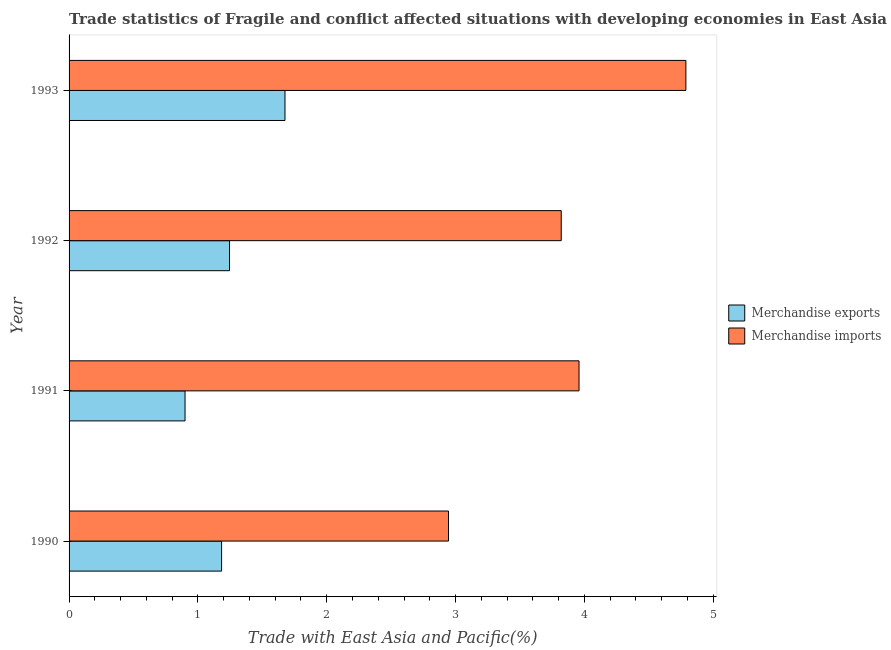How many groups of bars are there?
Make the answer very short. 4. Are the number of bars on each tick of the Y-axis equal?
Make the answer very short. Yes. In how many cases, is the number of bars for a given year not equal to the number of legend labels?
Keep it short and to the point. 0. What is the merchandise imports in 1991?
Offer a terse response. 3.96. Across all years, what is the maximum merchandise exports?
Provide a succinct answer. 1.68. Across all years, what is the minimum merchandise imports?
Keep it short and to the point. 2.95. What is the total merchandise imports in the graph?
Your response must be concise. 15.51. What is the difference between the merchandise exports in 1990 and that in 1992?
Your response must be concise. -0.06. What is the difference between the merchandise imports in 1990 and the merchandise exports in 1991?
Your answer should be very brief. 2.04. What is the average merchandise imports per year?
Keep it short and to the point. 3.88. In the year 1991, what is the difference between the merchandise exports and merchandise imports?
Ensure brevity in your answer.  -3.06. What is the ratio of the merchandise imports in 1991 to that in 1992?
Offer a very short reply. 1.04. Is the merchandise imports in 1990 less than that in 1992?
Your answer should be very brief. Yes. Is the difference between the merchandise exports in 1990 and 1991 greater than the difference between the merchandise imports in 1990 and 1991?
Offer a very short reply. Yes. What is the difference between the highest and the second highest merchandise imports?
Ensure brevity in your answer.  0.83. What is the difference between the highest and the lowest merchandise imports?
Provide a succinct answer. 1.84. In how many years, is the merchandise exports greater than the average merchandise exports taken over all years?
Provide a succinct answer. 1. Is the sum of the merchandise imports in 1990 and 1993 greater than the maximum merchandise exports across all years?
Ensure brevity in your answer.  Yes. What is the difference between two consecutive major ticks on the X-axis?
Your answer should be compact. 1. Are the values on the major ticks of X-axis written in scientific E-notation?
Give a very brief answer. No. Does the graph contain grids?
Provide a short and direct response. No. Where does the legend appear in the graph?
Give a very brief answer. Center right. How many legend labels are there?
Provide a succinct answer. 2. How are the legend labels stacked?
Offer a terse response. Vertical. What is the title of the graph?
Provide a short and direct response. Trade statistics of Fragile and conflict affected situations with developing economies in East Asia. Does "By country of asylum" appear as one of the legend labels in the graph?
Ensure brevity in your answer.  No. What is the label or title of the X-axis?
Provide a succinct answer. Trade with East Asia and Pacific(%). What is the label or title of the Y-axis?
Your answer should be very brief. Year. What is the Trade with East Asia and Pacific(%) of Merchandise exports in 1990?
Your answer should be compact. 1.18. What is the Trade with East Asia and Pacific(%) in Merchandise imports in 1990?
Offer a very short reply. 2.95. What is the Trade with East Asia and Pacific(%) of Merchandise exports in 1991?
Provide a succinct answer. 0.9. What is the Trade with East Asia and Pacific(%) in Merchandise imports in 1991?
Your response must be concise. 3.96. What is the Trade with East Asia and Pacific(%) of Merchandise exports in 1992?
Your response must be concise. 1.25. What is the Trade with East Asia and Pacific(%) of Merchandise imports in 1992?
Offer a very short reply. 3.82. What is the Trade with East Asia and Pacific(%) of Merchandise exports in 1993?
Provide a short and direct response. 1.68. What is the Trade with East Asia and Pacific(%) of Merchandise imports in 1993?
Give a very brief answer. 4.79. Across all years, what is the maximum Trade with East Asia and Pacific(%) in Merchandise exports?
Your answer should be very brief. 1.68. Across all years, what is the maximum Trade with East Asia and Pacific(%) of Merchandise imports?
Give a very brief answer. 4.79. Across all years, what is the minimum Trade with East Asia and Pacific(%) in Merchandise exports?
Give a very brief answer. 0.9. Across all years, what is the minimum Trade with East Asia and Pacific(%) of Merchandise imports?
Keep it short and to the point. 2.95. What is the total Trade with East Asia and Pacific(%) of Merchandise exports in the graph?
Ensure brevity in your answer.  5.01. What is the total Trade with East Asia and Pacific(%) of Merchandise imports in the graph?
Make the answer very short. 15.51. What is the difference between the Trade with East Asia and Pacific(%) in Merchandise exports in 1990 and that in 1991?
Your answer should be compact. 0.28. What is the difference between the Trade with East Asia and Pacific(%) in Merchandise imports in 1990 and that in 1991?
Keep it short and to the point. -1.01. What is the difference between the Trade with East Asia and Pacific(%) in Merchandise exports in 1990 and that in 1992?
Your answer should be very brief. -0.06. What is the difference between the Trade with East Asia and Pacific(%) of Merchandise imports in 1990 and that in 1992?
Your answer should be very brief. -0.88. What is the difference between the Trade with East Asia and Pacific(%) of Merchandise exports in 1990 and that in 1993?
Your answer should be compact. -0.49. What is the difference between the Trade with East Asia and Pacific(%) of Merchandise imports in 1990 and that in 1993?
Keep it short and to the point. -1.84. What is the difference between the Trade with East Asia and Pacific(%) in Merchandise exports in 1991 and that in 1992?
Your answer should be compact. -0.35. What is the difference between the Trade with East Asia and Pacific(%) in Merchandise imports in 1991 and that in 1992?
Make the answer very short. 0.14. What is the difference between the Trade with East Asia and Pacific(%) in Merchandise exports in 1991 and that in 1993?
Keep it short and to the point. -0.78. What is the difference between the Trade with East Asia and Pacific(%) in Merchandise imports in 1991 and that in 1993?
Ensure brevity in your answer.  -0.83. What is the difference between the Trade with East Asia and Pacific(%) in Merchandise exports in 1992 and that in 1993?
Ensure brevity in your answer.  -0.43. What is the difference between the Trade with East Asia and Pacific(%) in Merchandise imports in 1992 and that in 1993?
Ensure brevity in your answer.  -0.97. What is the difference between the Trade with East Asia and Pacific(%) of Merchandise exports in 1990 and the Trade with East Asia and Pacific(%) of Merchandise imports in 1991?
Provide a short and direct response. -2.77. What is the difference between the Trade with East Asia and Pacific(%) of Merchandise exports in 1990 and the Trade with East Asia and Pacific(%) of Merchandise imports in 1992?
Ensure brevity in your answer.  -2.64. What is the difference between the Trade with East Asia and Pacific(%) of Merchandise exports in 1990 and the Trade with East Asia and Pacific(%) of Merchandise imports in 1993?
Offer a very short reply. -3.6. What is the difference between the Trade with East Asia and Pacific(%) of Merchandise exports in 1991 and the Trade with East Asia and Pacific(%) of Merchandise imports in 1992?
Keep it short and to the point. -2.92. What is the difference between the Trade with East Asia and Pacific(%) of Merchandise exports in 1991 and the Trade with East Asia and Pacific(%) of Merchandise imports in 1993?
Your answer should be very brief. -3.89. What is the difference between the Trade with East Asia and Pacific(%) in Merchandise exports in 1992 and the Trade with East Asia and Pacific(%) in Merchandise imports in 1993?
Give a very brief answer. -3.54. What is the average Trade with East Asia and Pacific(%) in Merchandise exports per year?
Make the answer very short. 1.25. What is the average Trade with East Asia and Pacific(%) in Merchandise imports per year?
Give a very brief answer. 3.88. In the year 1990, what is the difference between the Trade with East Asia and Pacific(%) of Merchandise exports and Trade with East Asia and Pacific(%) of Merchandise imports?
Make the answer very short. -1.76. In the year 1991, what is the difference between the Trade with East Asia and Pacific(%) of Merchandise exports and Trade with East Asia and Pacific(%) of Merchandise imports?
Make the answer very short. -3.06. In the year 1992, what is the difference between the Trade with East Asia and Pacific(%) in Merchandise exports and Trade with East Asia and Pacific(%) in Merchandise imports?
Offer a terse response. -2.57. In the year 1993, what is the difference between the Trade with East Asia and Pacific(%) of Merchandise exports and Trade with East Asia and Pacific(%) of Merchandise imports?
Your response must be concise. -3.11. What is the ratio of the Trade with East Asia and Pacific(%) in Merchandise exports in 1990 to that in 1991?
Offer a terse response. 1.32. What is the ratio of the Trade with East Asia and Pacific(%) of Merchandise imports in 1990 to that in 1991?
Provide a succinct answer. 0.74. What is the ratio of the Trade with East Asia and Pacific(%) in Merchandise exports in 1990 to that in 1992?
Give a very brief answer. 0.95. What is the ratio of the Trade with East Asia and Pacific(%) in Merchandise imports in 1990 to that in 1992?
Provide a short and direct response. 0.77. What is the ratio of the Trade with East Asia and Pacific(%) of Merchandise exports in 1990 to that in 1993?
Offer a terse response. 0.71. What is the ratio of the Trade with East Asia and Pacific(%) in Merchandise imports in 1990 to that in 1993?
Give a very brief answer. 0.62. What is the ratio of the Trade with East Asia and Pacific(%) of Merchandise exports in 1991 to that in 1992?
Your answer should be compact. 0.72. What is the ratio of the Trade with East Asia and Pacific(%) of Merchandise imports in 1991 to that in 1992?
Your answer should be very brief. 1.04. What is the ratio of the Trade with East Asia and Pacific(%) of Merchandise exports in 1991 to that in 1993?
Offer a very short reply. 0.54. What is the ratio of the Trade with East Asia and Pacific(%) of Merchandise imports in 1991 to that in 1993?
Provide a short and direct response. 0.83. What is the ratio of the Trade with East Asia and Pacific(%) in Merchandise exports in 1992 to that in 1993?
Provide a succinct answer. 0.74. What is the ratio of the Trade with East Asia and Pacific(%) of Merchandise imports in 1992 to that in 1993?
Give a very brief answer. 0.8. What is the difference between the highest and the second highest Trade with East Asia and Pacific(%) of Merchandise exports?
Ensure brevity in your answer.  0.43. What is the difference between the highest and the second highest Trade with East Asia and Pacific(%) of Merchandise imports?
Offer a terse response. 0.83. What is the difference between the highest and the lowest Trade with East Asia and Pacific(%) in Merchandise exports?
Provide a succinct answer. 0.78. What is the difference between the highest and the lowest Trade with East Asia and Pacific(%) in Merchandise imports?
Keep it short and to the point. 1.84. 